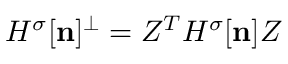<formula> <loc_0><loc_0><loc_500><loc_500>{ H ^ { \sigma } } [ { n } ] ^ { \perp } = Z ^ { T } { H ^ { \sigma } } [ { n } ] Z</formula> 